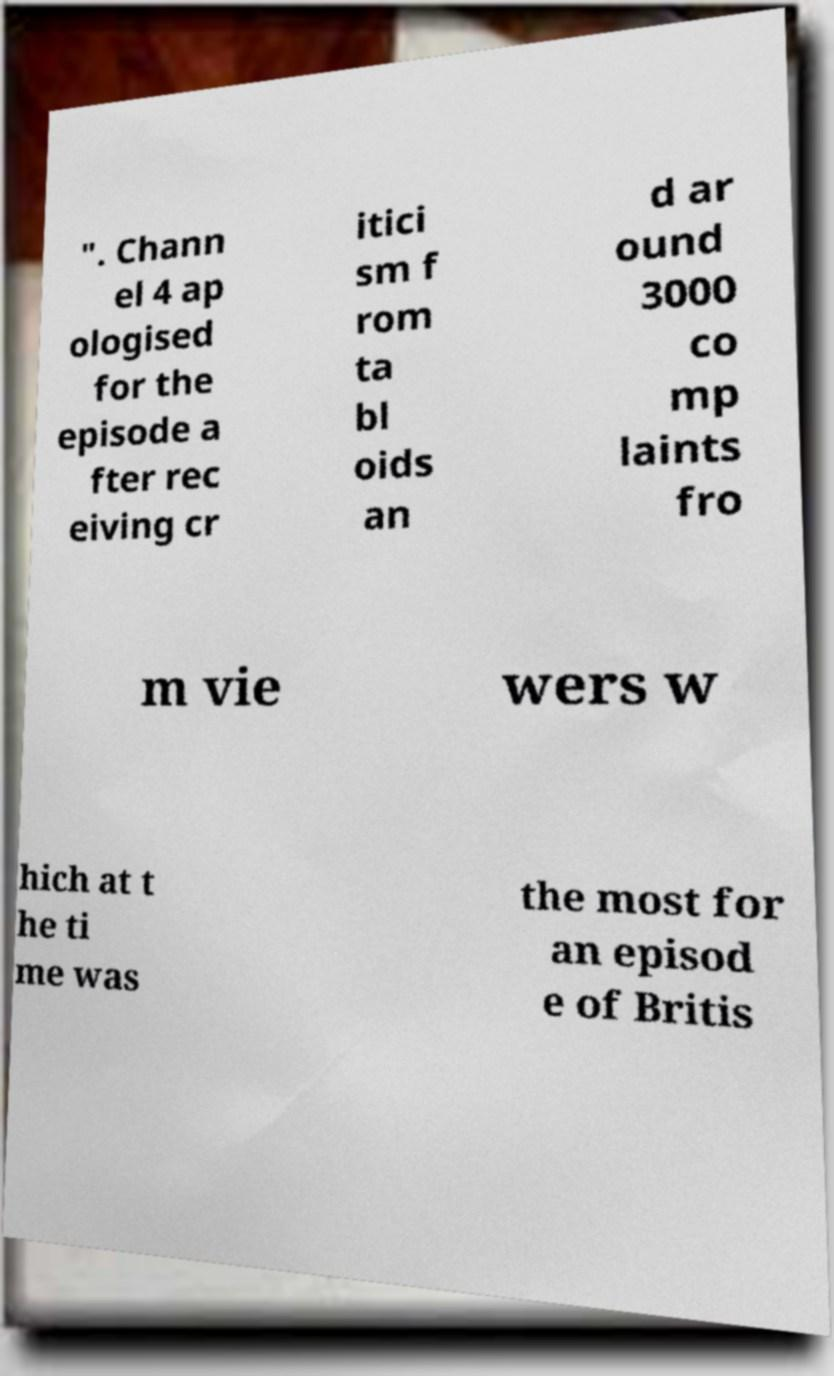Please read and relay the text visible in this image. What does it say? ". Chann el 4 ap ologised for the episode a fter rec eiving cr itici sm f rom ta bl oids an d ar ound 3000 co mp laints fro m vie wers w hich at t he ti me was the most for an episod e of Britis 